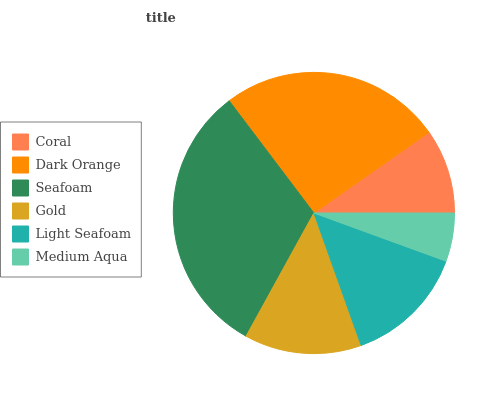Is Medium Aqua the minimum?
Answer yes or no. Yes. Is Seafoam the maximum?
Answer yes or no. Yes. Is Dark Orange the minimum?
Answer yes or no. No. Is Dark Orange the maximum?
Answer yes or no. No. Is Dark Orange greater than Coral?
Answer yes or no. Yes. Is Coral less than Dark Orange?
Answer yes or no. Yes. Is Coral greater than Dark Orange?
Answer yes or no. No. Is Dark Orange less than Coral?
Answer yes or no. No. Is Light Seafoam the high median?
Answer yes or no. Yes. Is Gold the low median?
Answer yes or no. Yes. Is Medium Aqua the high median?
Answer yes or no. No. Is Medium Aqua the low median?
Answer yes or no. No. 